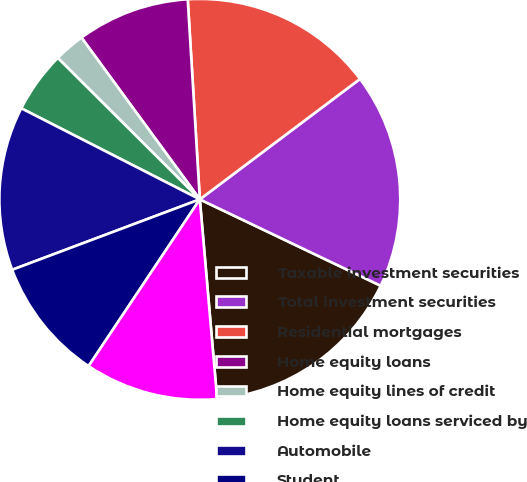Convert chart. <chart><loc_0><loc_0><loc_500><loc_500><pie_chart><fcel>Taxable investment securities<fcel>Total investment securities<fcel>Residential mortgages<fcel>Home equity loans<fcel>Home equity lines of credit<fcel>Home equity loans serviced by<fcel>Automobile<fcel>Student<fcel>Credit cards<nl><fcel>16.53%<fcel>17.35%<fcel>15.7%<fcel>9.09%<fcel>2.48%<fcel>4.96%<fcel>13.22%<fcel>9.92%<fcel>10.74%<nl></chart> 